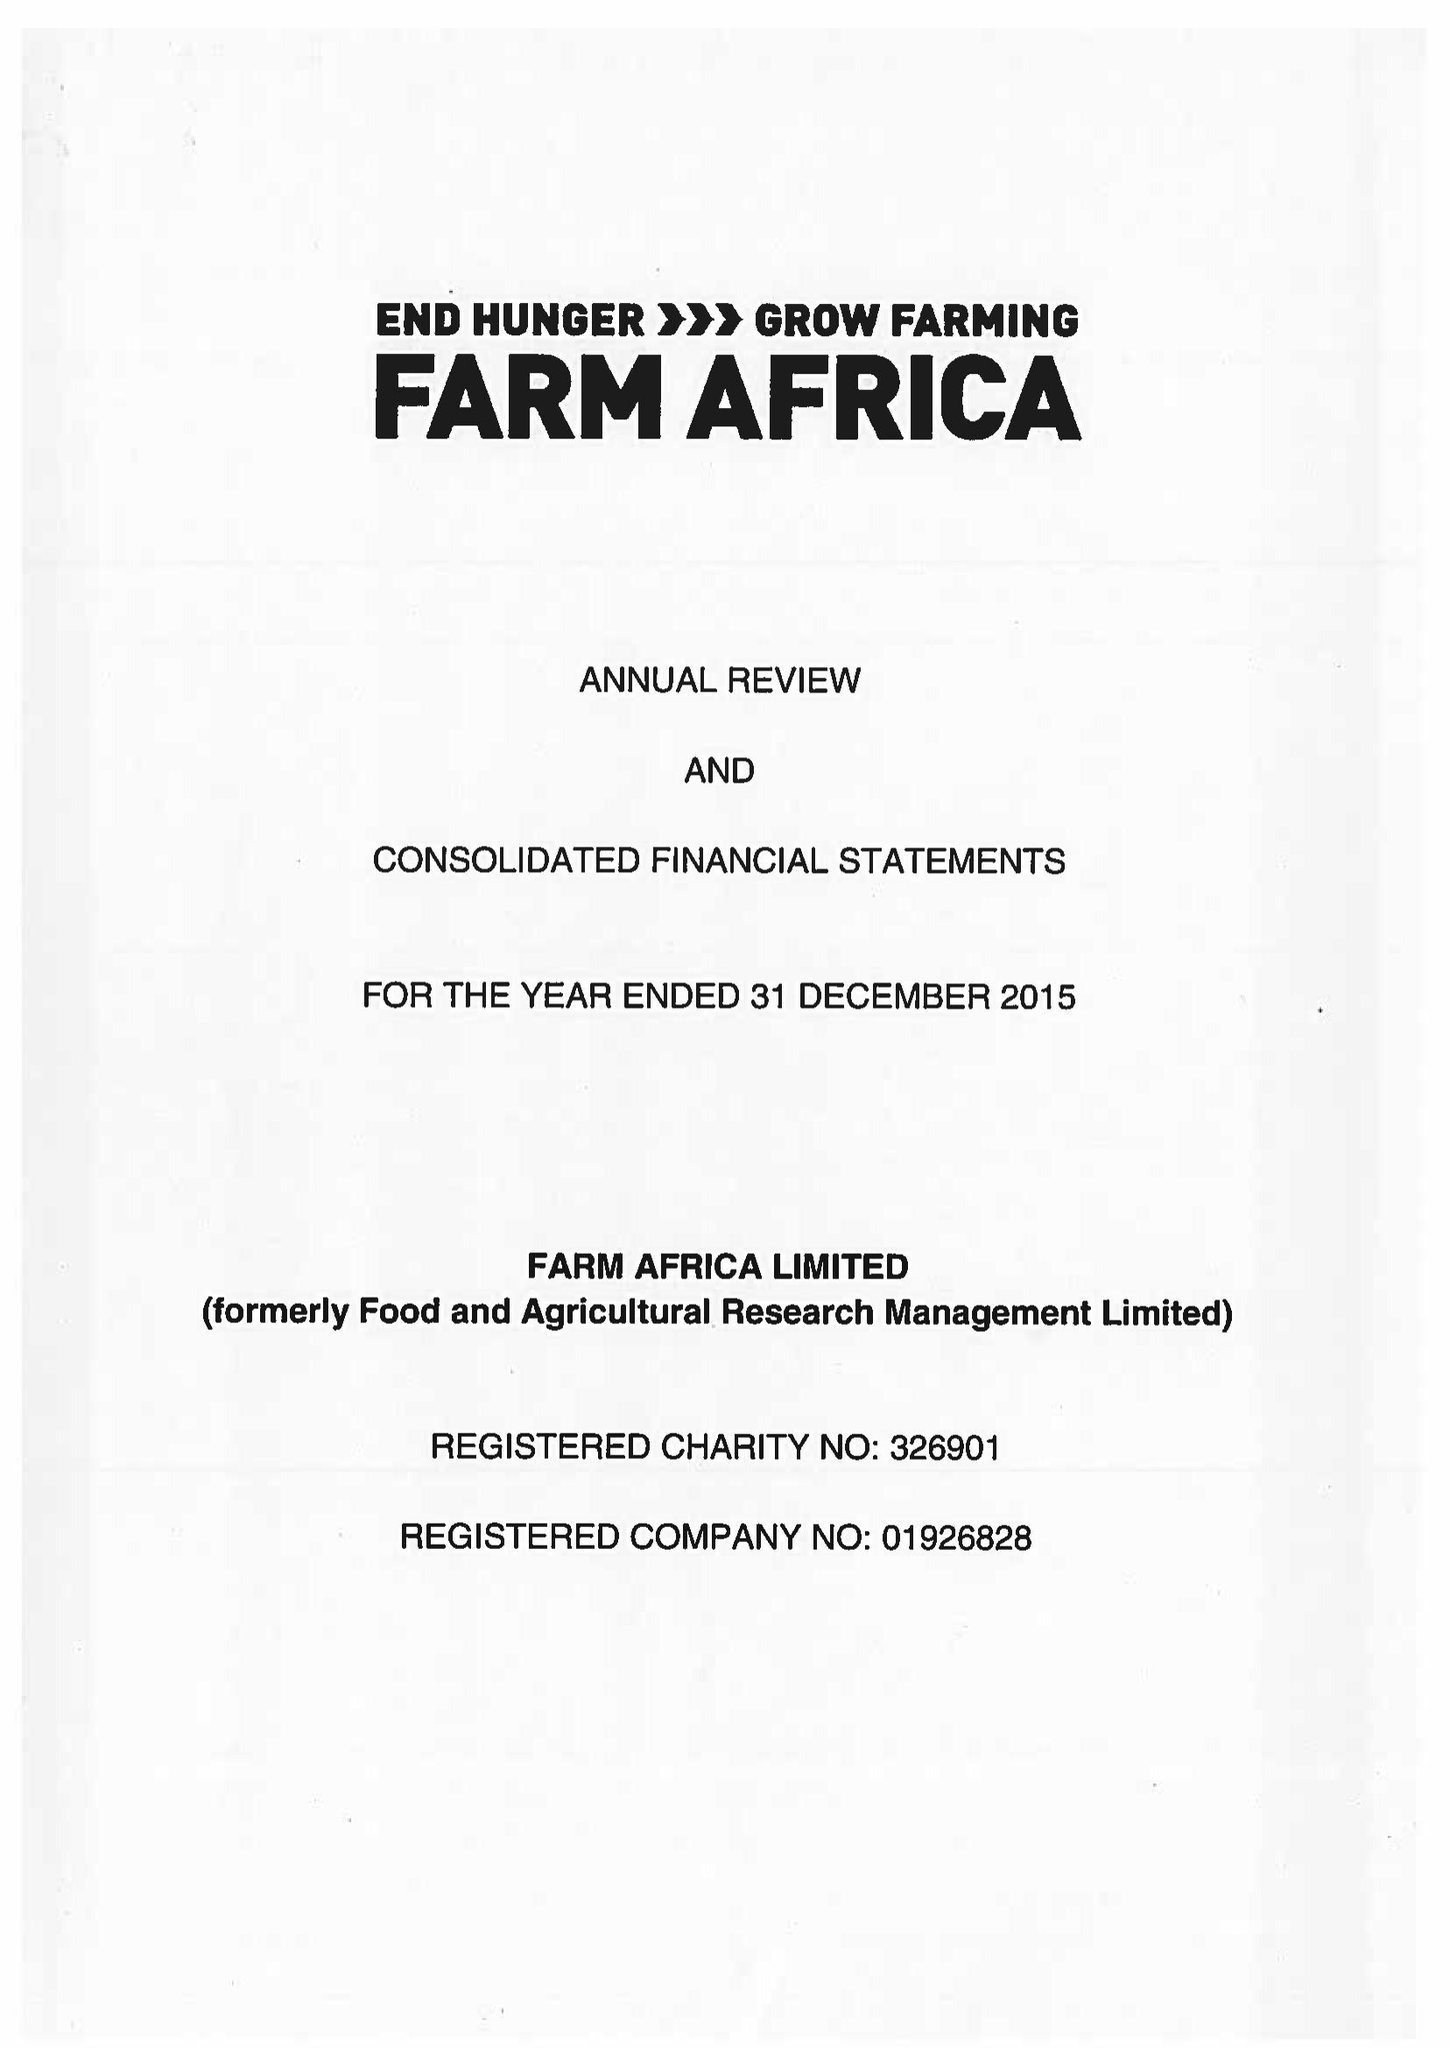What is the value for the charity_number?
Answer the question using a single word or phrase. 326901 